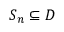Convert formula to latex. <formula><loc_0><loc_0><loc_500><loc_500>S _ { n } \subseteq D</formula> 